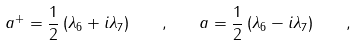<formula> <loc_0><loc_0><loc_500><loc_500>a ^ { + } = \frac { 1 } { 2 } \left ( \lambda _ { 6 } + i \lambda _ { 7 } \right ) \quad , \quad a = \frac { 1 } { 2 } \left ( \lambda _ { 6 } - i \lambda _ { 7 } \right ) \quad ,</formula> 